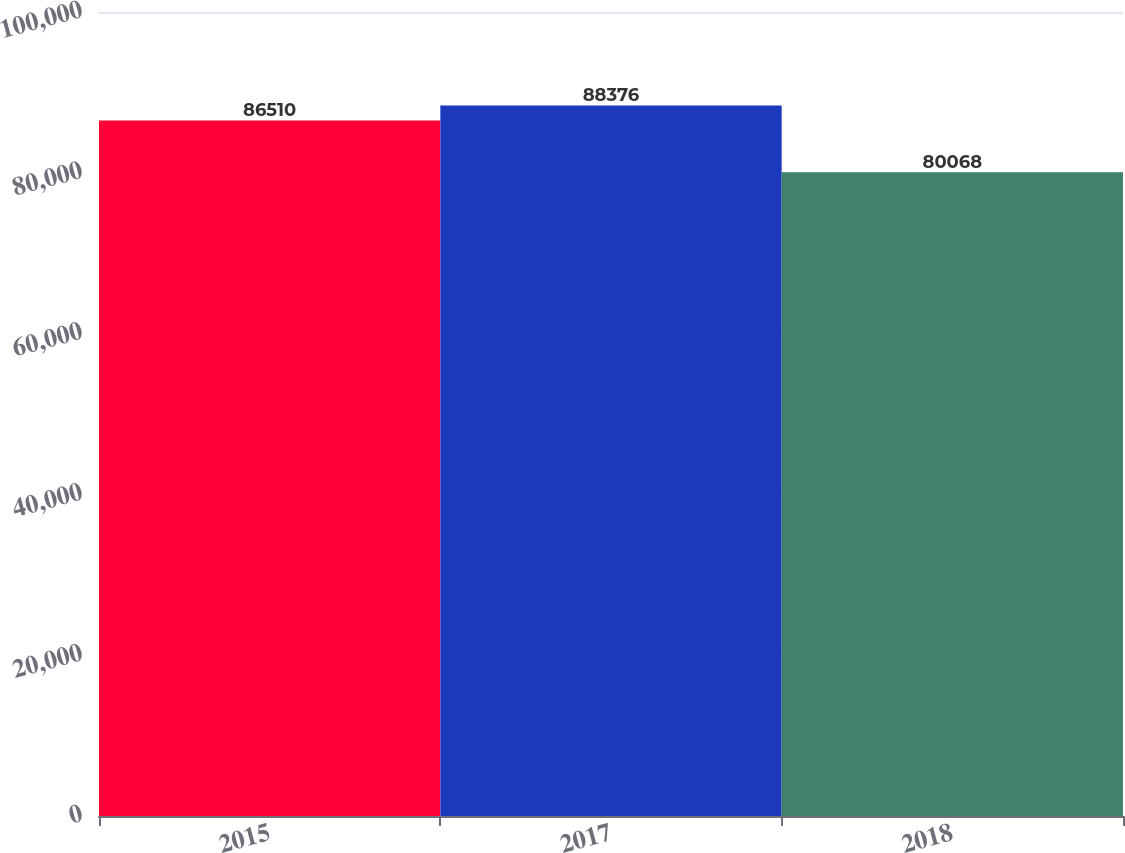<chart> <loc_0><loc_0><loc_500><loc_500><bar_chart><fcel>2015<fcel>2017<fcel>2018<nl><fcel>86510<fcel>88376<fcel>80068<nl></chart> 